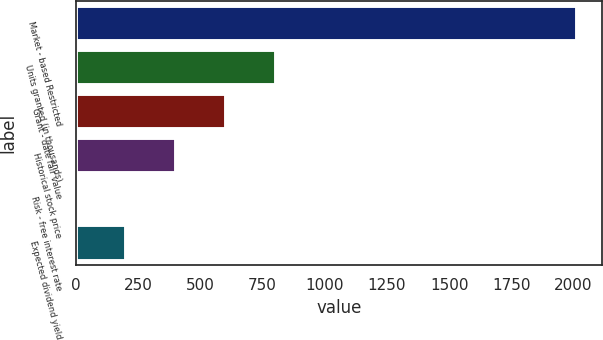Convert chart to OTSL. <chart><loc_0><loc_0><loc_500><loc_500><bar_chart><fcel>Market - based Restricted<fcel>Units granted (in thousands)<fcel>Grant - date fair value<fcel>Historical stock price<fcel>Risk - free interest rate<fcel>Expected dividend yield<nl><fcel>2014<fcel>806.08<fcel>604.76<fcel>403.44<fcel>0.8<fcel>202.12<nl></chart> 